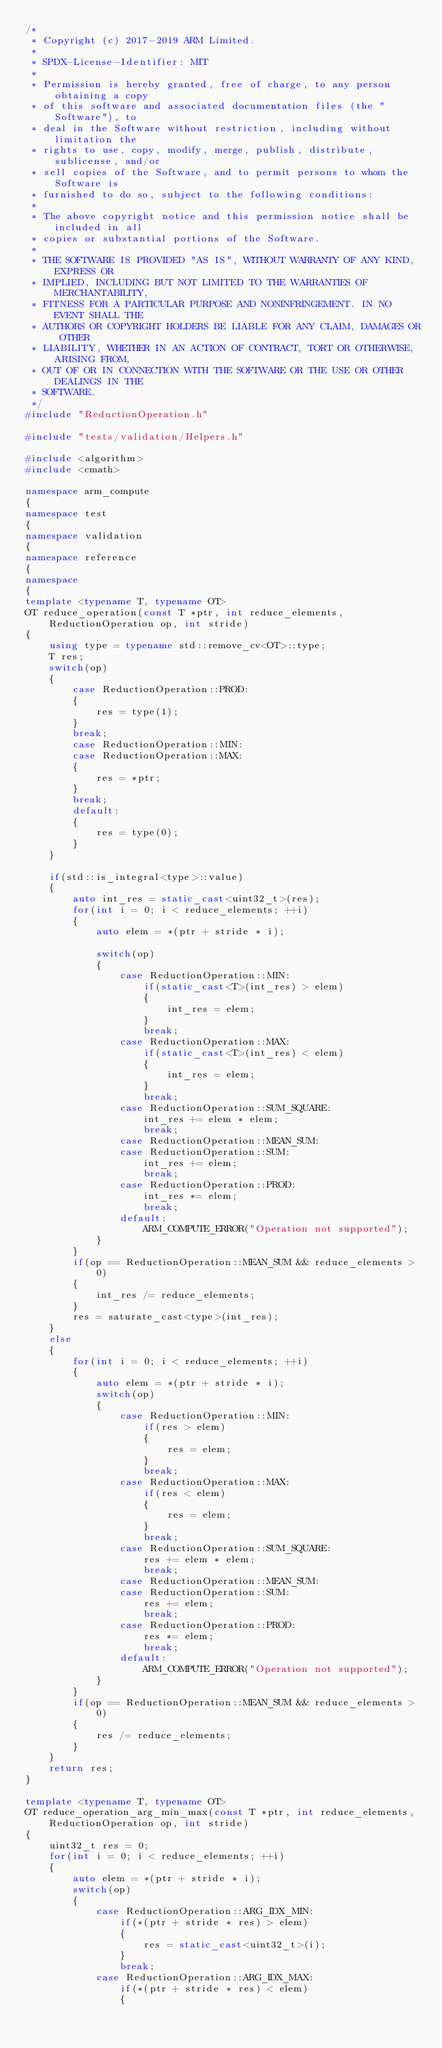<code> <loc_0><loc_0><loc_500><loc_500><_C++_>/*
 * Copyright (c) 2017-2019 ARM Limited.
 *
 * SPDX-License-Identifier: MIT
 *
 * Permission is hereby granted, free of charge, to any person obtaining a copy
 * of this software and associated documentation files (the "Software"), to
 * deal in the Software without restriction, including without limitation the
 * rights to use, copy, modify, merge, publish, distribute, sublicense, and/or
 * sell copies of the Software, and to permit persons to whom the Software is
 * furnished to do so, subject to the following conditions:
 *
 * The above copyright notice and this permission notice shall be included in all
 * copies or substantial portions of the Software.
 *
 * THE SOFTWARE IS PROVIDED "AS IS", WITHOUT WARRANTY OF ANY KIND, EXPRESS OR
 * IMPLIED, INCLUDING BUT NOT LIMITED TO THE WARRANTIES OF MERCHANTABILITY,
 * FITNESS FOR A PARTICULAR PURPOSE AND NONINFRINGEMENT. IN NO EVENT SHALL THE
 * AUTHORS OR COPYRIGHT HOLDERS BE LIABLE FOR ANY CLAIM, DAMAGES OR OTHER
 * LIABILITY, WHETHER IN AN ACTION OF CONTRACT, TORT OR OTHERWISE, ARISING FROM,
 * OUT OF OR IN CONNECTION WITH THE SOFTWARE OR THE USE OR OTHER DEALINGS IN THE
 * SOFTWARE.
 */
#include "ReductionOperation.h"

#include "tests/validation/Helpers.h"

#include <algorithm>
#include <cmath>

namespace arm_compute
{
namespace test
{
namespace validation
{
namespace reference
{
namespace
{
template <typename T, typename OT>
OT reduce_operation(const T *ptr, int reduce_elements, ReductionOperation op, int stride)
{
    using type = typename std::remove_cv<OT>::type;
    T res;
    switch(op)
    {
        case ReductionOperation::PROD:
        {
            res = type(1);
        }
        break;
        case ReductionOperation::MIN:
        case ReductionOperation::MAX:
        {
            res = *ptr;
        }
        break;
        default:
        {
            res = type(0);
        }
    }

    if(std::is_integral<type>::value)
    {
        auto int_res = static_cast<uint32_t>(res);
        for(int i = 0; i < reduce_elements; ++i)
        {
            auto elem = *(ptr + stride * i);

            switch(op)
            {
                case ReductionOperation::MIN:
                    if(static_cast<T>(int_res) > elem)
                    {
                        int_res = elem;
                    }
                    break;
                case ReductionOperation::MAX:
                    if(static_cast<T>(int_res) < elem)
                    {
                        int_res = elem;
                    }
                    break;
                case ReductionOperation::SUM_SQUARE:
                    int_res += elem * elem;
                    break;
                case ReductionOperation::MEAN_SUM:
                case ReductionOperation::SUM:
                    int_res += elem;
                    break;
                case ReductionOperation::PROD:
                    int_res *= elem;
                    break;
                default:
                    ARM_COMPUTE_ERROR("Operation not supported");
            }
        }
        if(op == ReductionOperation::MEAN_SUM && reduce_elements > 0)
        {
            int_res /= reduce_elements;
        }
        res = saturate_cast<type>(int_res);
    }
    else
    {
        for(int i = 0; i < reduce_elements; ++i)
        {
            auto elem = *(ptr + stride * i);
            switch(op)
            {
                case ReductionOperation::MIN:
                    if(res > elem)
                    {
                        res = elem;
                    }
                    break;
                case ReductionOperation::MAX:
                    if(res < elem)
                    {
                        res = elem;
                    }
                    break;
                case ReductionOperation::SUM_SQUARE:
                    res += elem * elem;
                    break;
                case ReductionOperation::MEAN_SUM:
                case ReductionOperation::SUM:
                    res += elem;
                    break;
                case ReductionOperation::PROD:
                    res *= elem;
                    break;
                default:
                    ARM_COMPUTE_ERROR("Operation not supported");
            }
        }
        if(op == ReductionOperation::MEAN_SUM && reduce_elements > 0)
        {
            res /= reduce_elements;
        }
    }
    return res;
}

template <typename T, typename OT>
OT reduce_operation_arg_min_max(const T *ptr, int reduce_elements, ReductionOperation op, int stride)
{
    uint32_t res = 0;
    for(int i = 0; i < reduce_elements; ++i)
    {
        auto elem = *(ptr + stride * i);
        switch(op)
        {
            case ReductionOperation::ARG_IDX_MIN:
                if(*(ptr + stride * res) > elem)
                {
                    res = static_cast<uint32_t>(i);
                }
                break;
            case ReductionOperation::ARG_IDX_MAX:
                if(*(ptr + stride * res) < elem)
                {</code> 